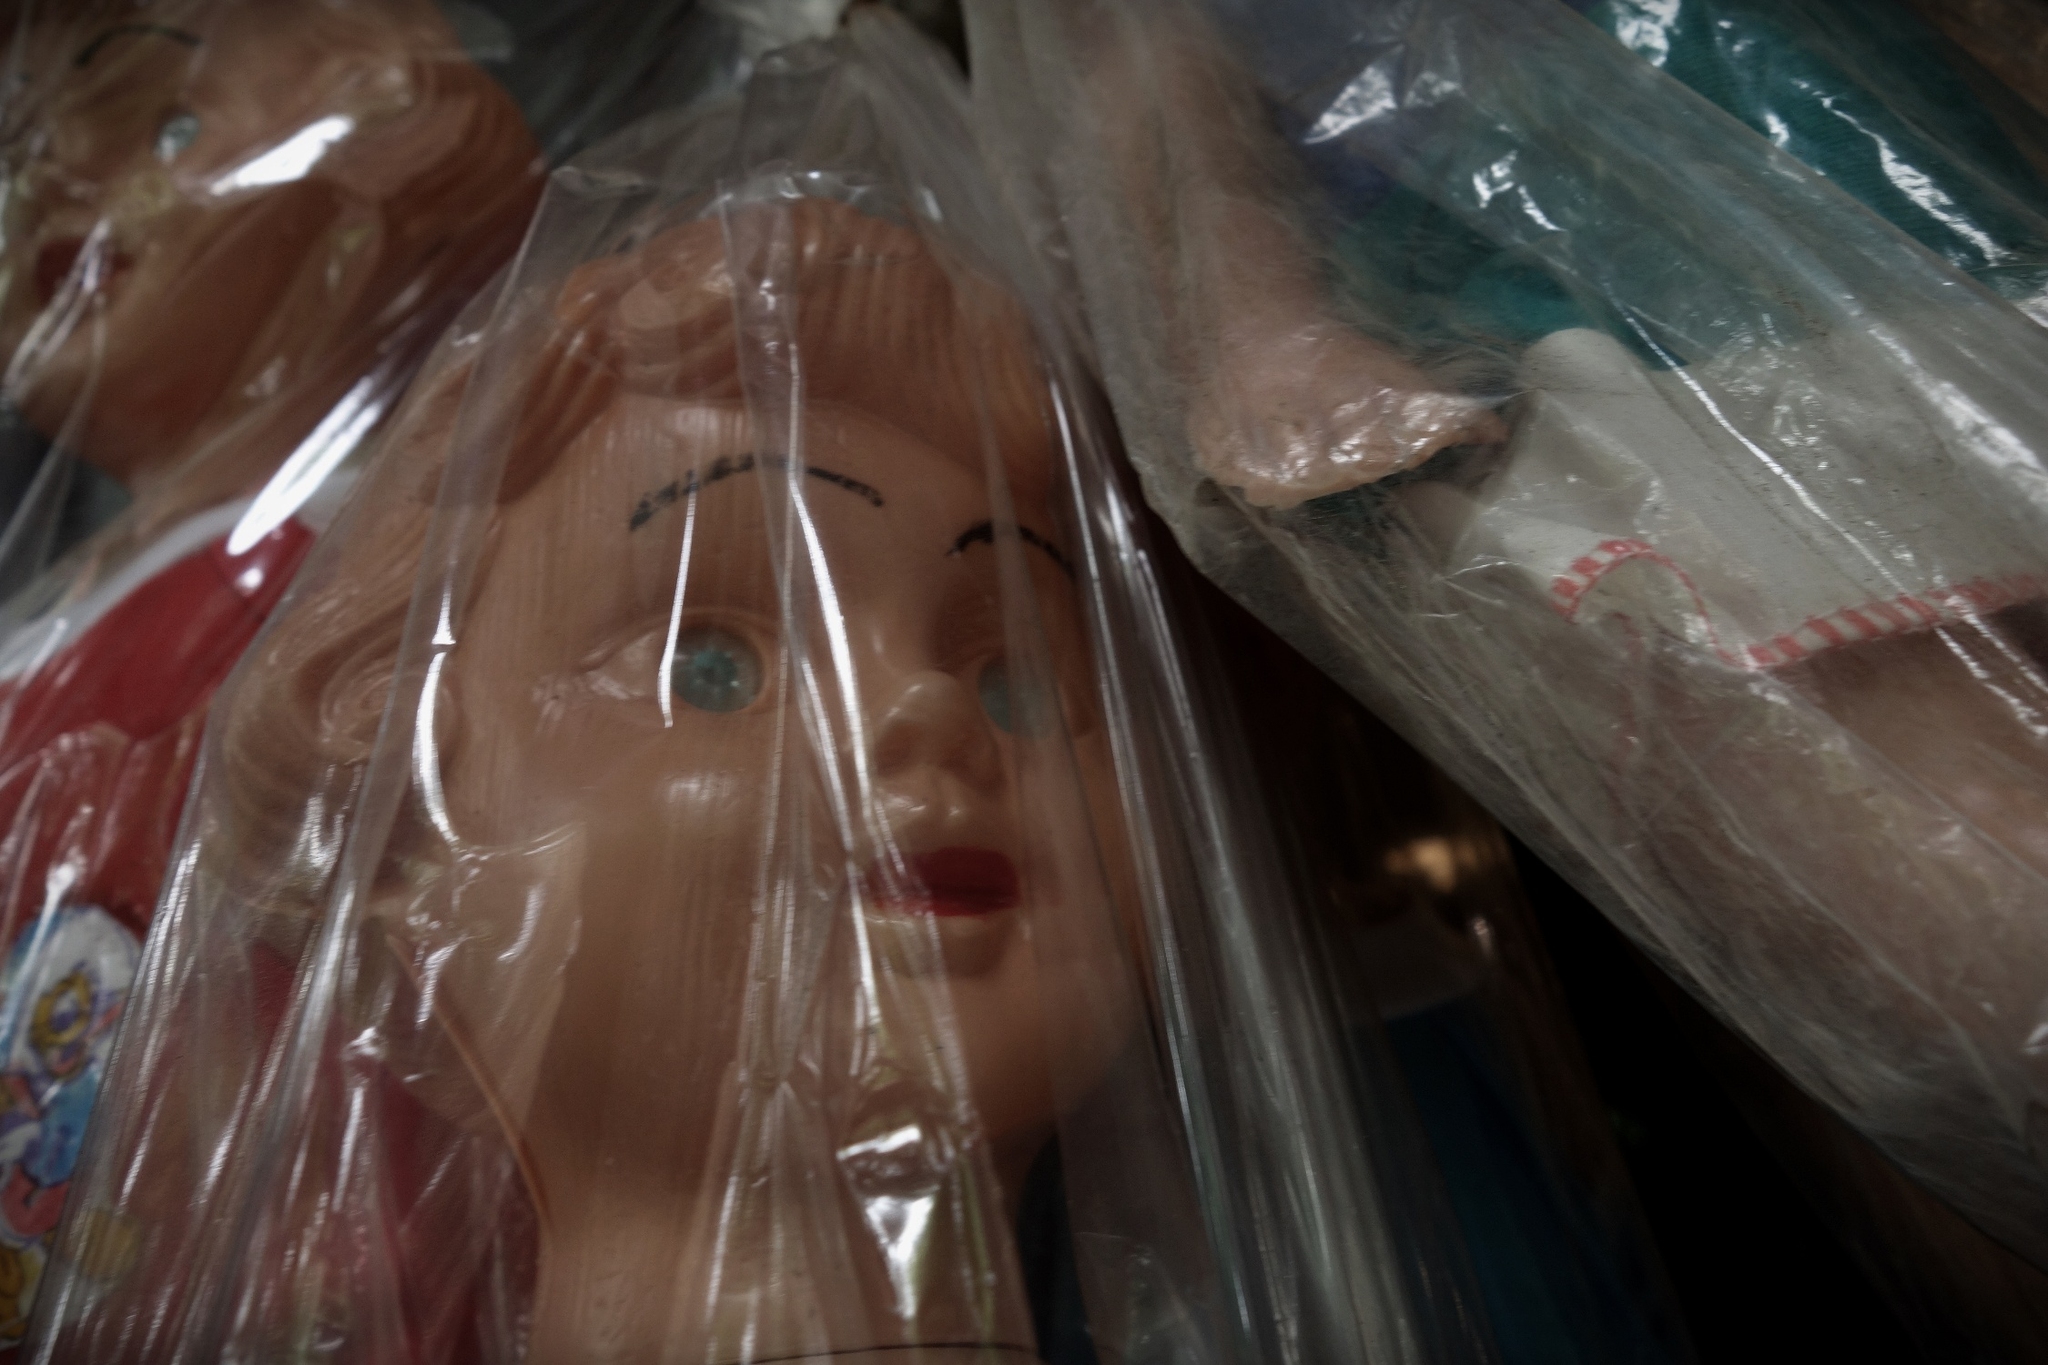What does the arrangement of the dolls suggest to you? The arrangement of the dolls, each carefully encased in plastic bags, suggests a setting where preservation and protection are prioritized. This could imply that the dolls are part of a valuable collection, possibly owned by an avid doll collector. The use of plastic bags indicates an effort to protect the dolls from dust, moisture, and other potential damage. The meticulous organization further emphasizes the care and attention given to maintaining the pristine condition of each doll in the collection. 